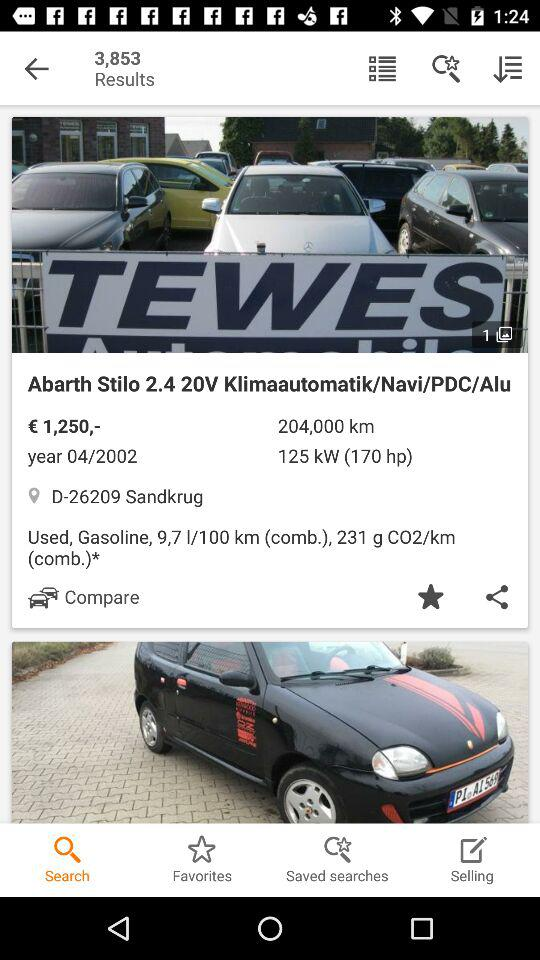What is the year? The year is 2002. 